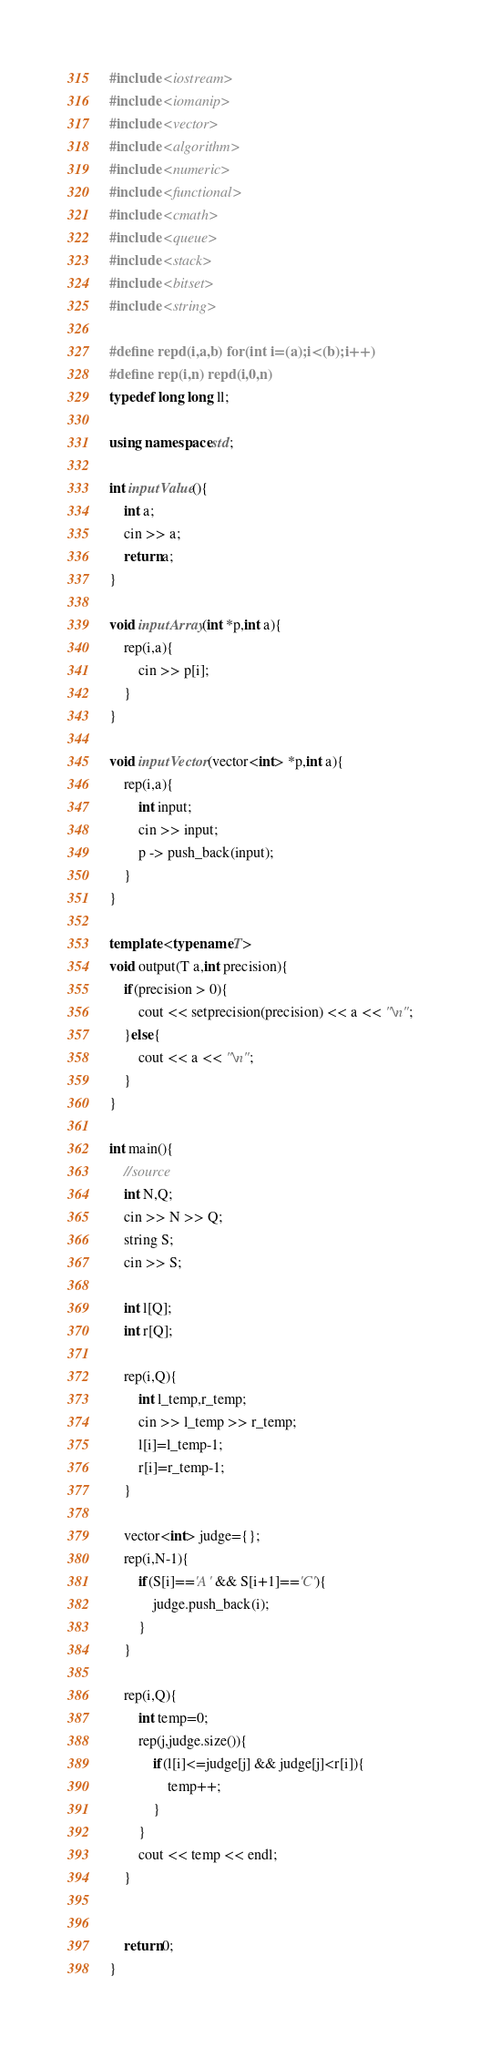Convert code to text. <code><loc_0><loc_0><loc_500><loc_500><_C++_>#include <iostream>
#include <iomanip>
#include <vector>
#include <algorithm>
#include <numeric>
#include <functional>
#include <cmath>
#include <queue>
#include <stack>
#include <bitset>
#include <string>

#define repd(i,a,b) for(int i=(a);i<(b);i++)
#define rep(i,n) repd(i,0,n)
typedef long long ll;

using namespace std;

int inputValue(){
	int a;
	cin >> a;
	return a;
}

void inputArray(int *p,int a){
	rep(i,a){
		cin >> p[i];
	}
}

void inputVector(vector<int> *p,int a){
	rep(i,a){
		int input;
		cin >> input;
		p -> push_back(input);
	}
}

template <typename T>
void output(T a,int precision){
	if(precision > 0){
		cout << setprecision(precision) << a << "\n";
	}else{
		cout << a << "\n";
	}
}

int main(){
	//source
	int N,Q;
	cin >> N >> Q;
	string S;
	cin >> S;

	int l[Q];
	int r[Q];

	rep(i,Q){
		int l_temp,r_temp;
		cin >> l_temp >> r_temp;
		l[i]=l_temp-1;
		r[i]=r_temp-1;
	}
	
	vector<int> judge={};
	rep(i,N-1){
		if(S[i]=='A' && S[i+1]=='C'){
			judge.push_back(i);
		}
	}

	rep(i,Q){
		int temp=0;
		rep(j,judge.size()){
			if(l[i]<=judge[j] && judge[j]<r[i]){
				temp++;
			}
		}
		cout << temp << endl;
	}


	return 0;
}
</code> 